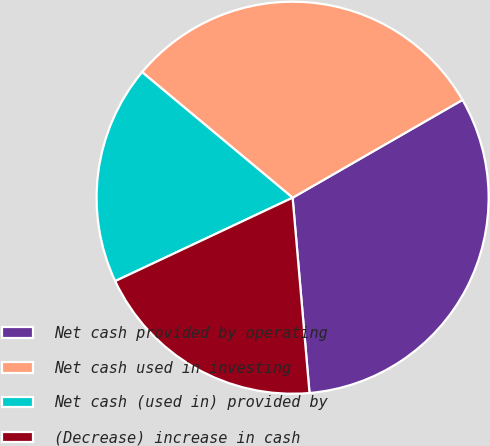Convert chart to OTSL. <chart><loc_0><loc_0><loc_500><loc_500><pie_chart><fcel>Net cash provided by operating<fcel>Net cash used in investing<fcel>Net cash (used in) provided by<fcel>(Decrease) increase in cash<nl><fcel>31.94%<fcel>30.62%<fcel>18.06%<fcel>19.38%<nl></chart> 